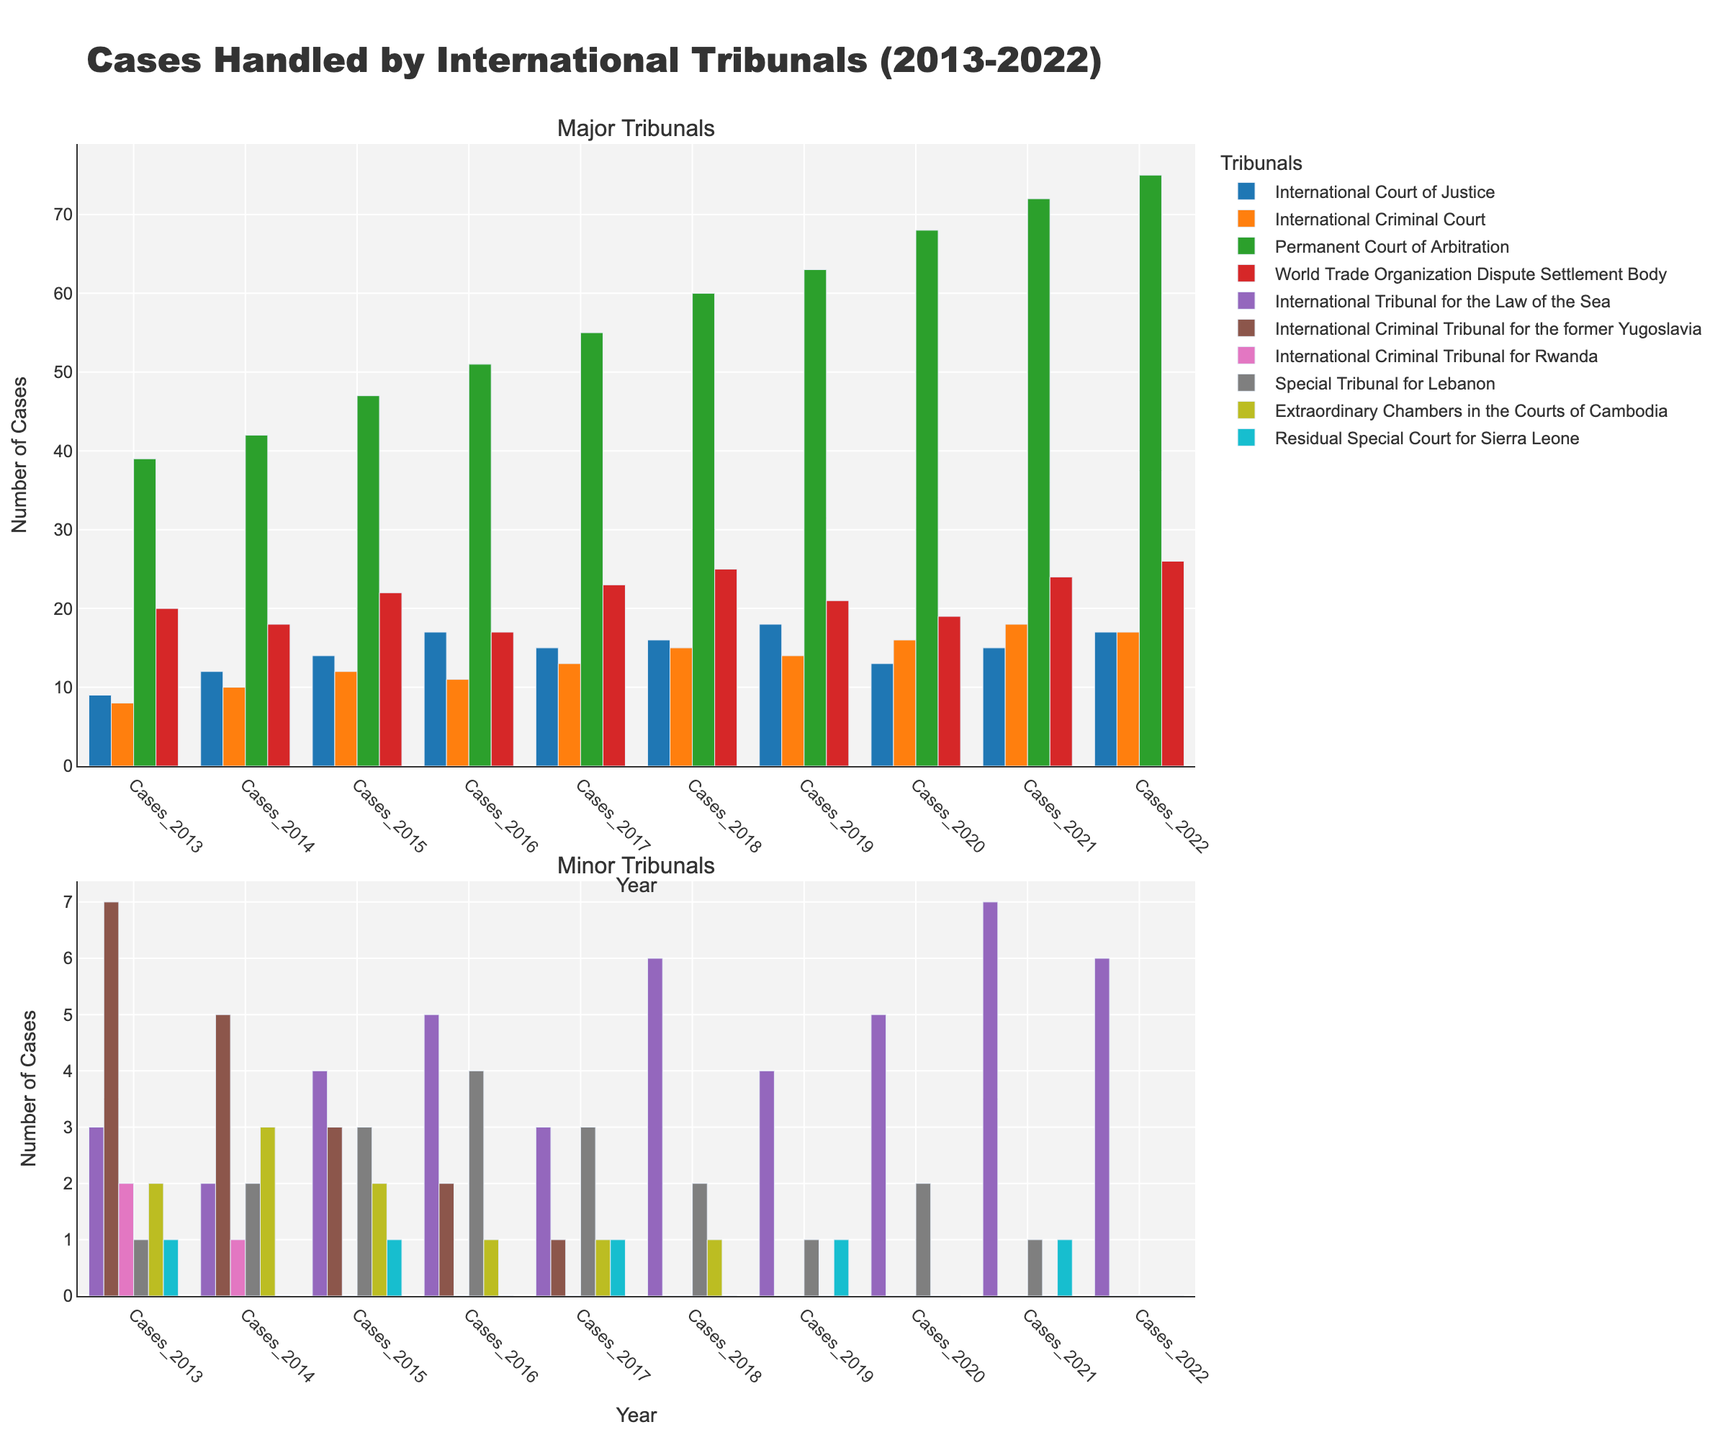How many cases did the Permanent Court of Arbitration handle in total from 2013 to 2022? Sum the number of cases handled each year from 2013 to 2022: 39 + 42 + 47 + 51 + 55 + 60 + 63 + 68 + 72 + 75 = 572
Answer: 572 Which tribunal had the highest number of cases in 2019? Compare the number of cases handled by each tribunal in 2019, the Permanent Court of Arbitration had 63, which is the highest.
Answer: Permanent Court of Arbitration How did the number of cases handled by the International Criminal Tribunal for the former Yugoslavia change over time? Track the number of cases from 2013 to 2022: 7 -> 5 -> 3 -> 2 -> 1 -> 0 -> 0 -> 0 -> 0 -> 0. The number of cases decreased and then remained at zero.
Answer: Decreased to zero What is the average number of cases handled per year by the International Tribunal for the Law of the Sea from 2013 to 2022? Sum the number of cases for each year and divide by the number of years: (3 + 2 + 4 + 5 + 3 + 6 + 4 + 5 + 7 + 6) / 10 = 45 / 10 = 4.5
Answer: 4.5 Compare the number of cases handled by the International Court of Justice and the International Criminal Court in 2020. The International Court of Justice handled 13 cases while the International Criminal Court handled 16 cases in 2020. The International Criminal Court handled more cases.
Answer: International Criminal Court Which tribunal handled the least number of cases in 2015? Compare the number of cases handled by each tribunal in 2015: The International Criminal Tribunal for Rwanda handled 0 cases, which is the least.
Answer: International Criminal Tribunal for Rwanda Which tribunal showed a significant increase in the number of cases in 2018? Compare the number of cases in 2017 and 2018 for each tribunal: The International Tribunal for the Law of the Sea increased from 3 to 6 cases, which is a significant increase.
Answer: International Tribunal for the Law of the Sea What is the total number of cases handled by all tribunals in 2018? Sum the number of cases handled by all tribunals in 2018: 16 + 15 + 6 + 60 + 25 + 0 + 0 + 2 + 1 + 0 = 125
Answer: 125 